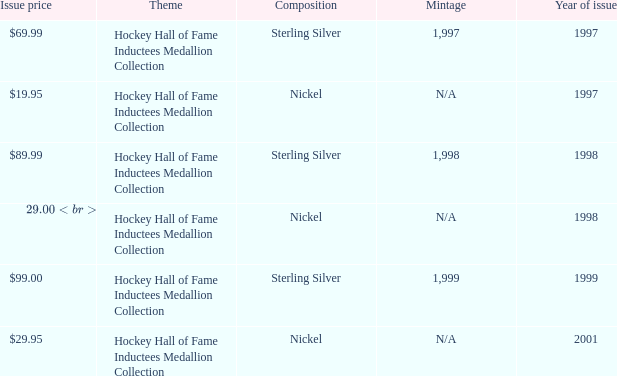How many years was the issue price $19.95? 1.0. 